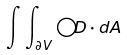Convert formula to latex. <formula><loc_0><loc_0><loc_500><loc_500>\int \int _ { \partial V } \bigcirc D \cdot d A</formula> 